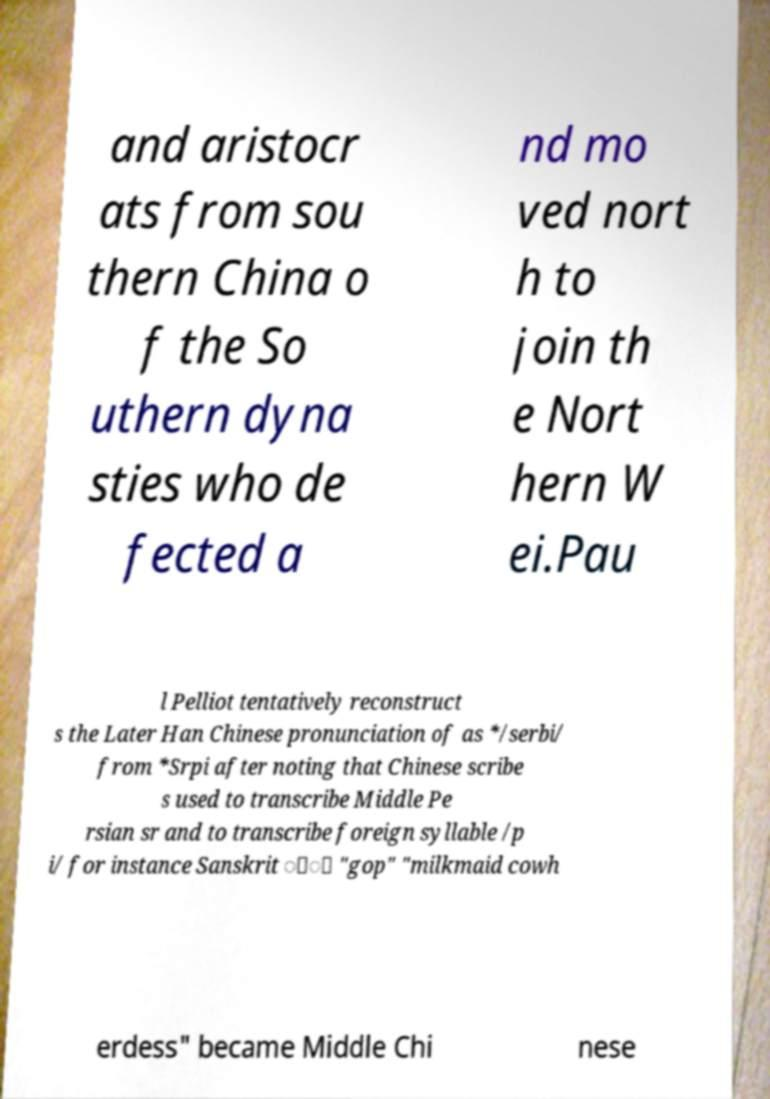What messages or text are displayed in this image? I need them in a readable, typed format. and aristocr ats from sou thern China o f the So uthern dyna sties who de fected a nd mo ved nort h to join th e Nort hern W ei.Pau l Pelliot tentatively reconstruct s the Later Han Chinese pronunciation of as */serbi/ from *Srpi after noting that Chinese scribe s used to transcribe Middle Pe rsian sr and to transcribe foreign syllable /p i/ for instance Sanskrit ोी "gop" "milkmaid cowh erdess" became Middle Chi nese 